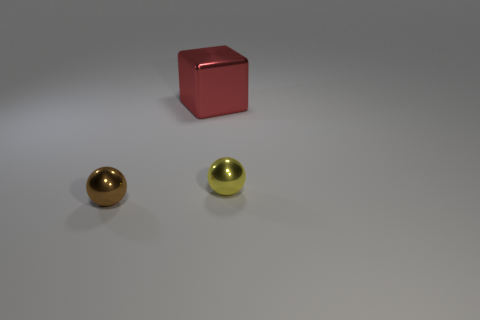Are there any cyan shiny cylinders of the same size as the cube? no 